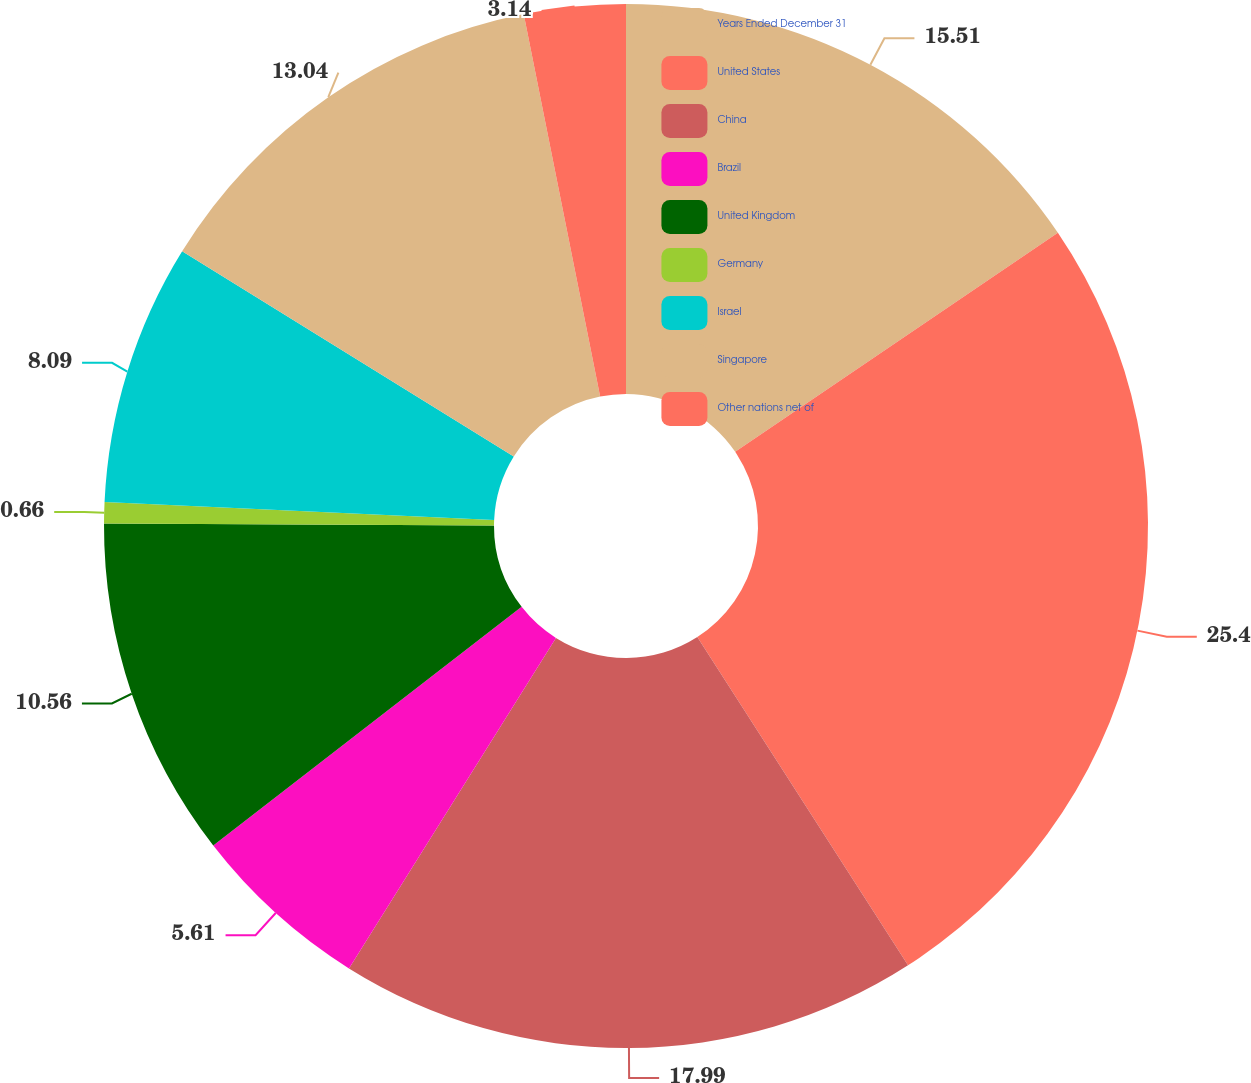Convert chart to OTSL. <chart><loc_0><loc_0><loc_500><loc_500><pie_chart><fcel>Years Ended December 31<fcel>United States<fcel>China<fcel>Brazil<fcel>United Kingdom<fcel>Germany<fcel>Israel<fcel>Singapore<fcel>Other nations net of<nl><fcel>15.51%<fcel>25.41%<fcel>17.99%<fcel>5.61%<fcel>10.56%<fcel>0.66%<fcel>8.09%<fcel>13.04%<fcel>3.14%<nl></chart> 